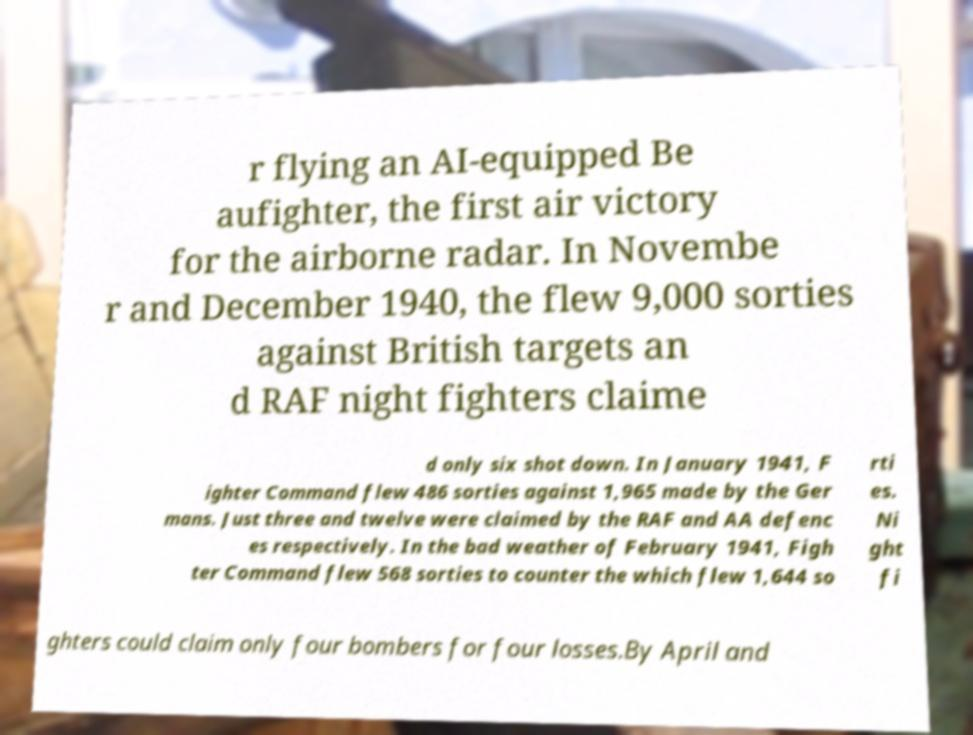Please read and relay the text visible in this image. What does it say? r flying an AI-equipped Be aufighter, the first air victory for the airborne radar. In Novembe r and December 1940, the flew 9,000 sorties against British targets an d RAF night fighters claime d only six shot down. In January 1941, F ighter Command flew 486 sorties against 1,965 made by the Ger mans. Just three and twelve were claimed by the RAF and AA defenc es respectively. In the bad weather of February 1941, Figh ter Command flew 568 sorties to counter the which flew 1,644 so rti es. Ni ght fi ghters could claim only four bombers for four losses.By April and 